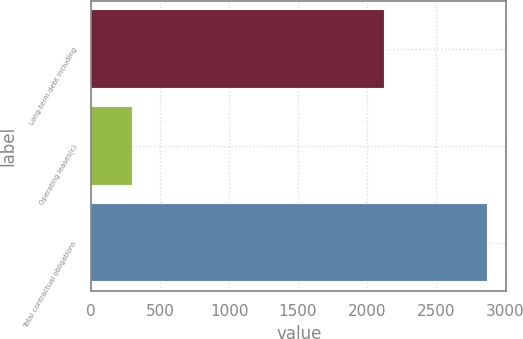<chart> <loc_0><loc_0><loc_500><loc_500><bar_chart><fcel>Long-term debt including<fcel>Operating leases(c)<fcel>Total contractual obligations<nl><fcel>2122<fcel>293<fcel>2868<nl></chart> 